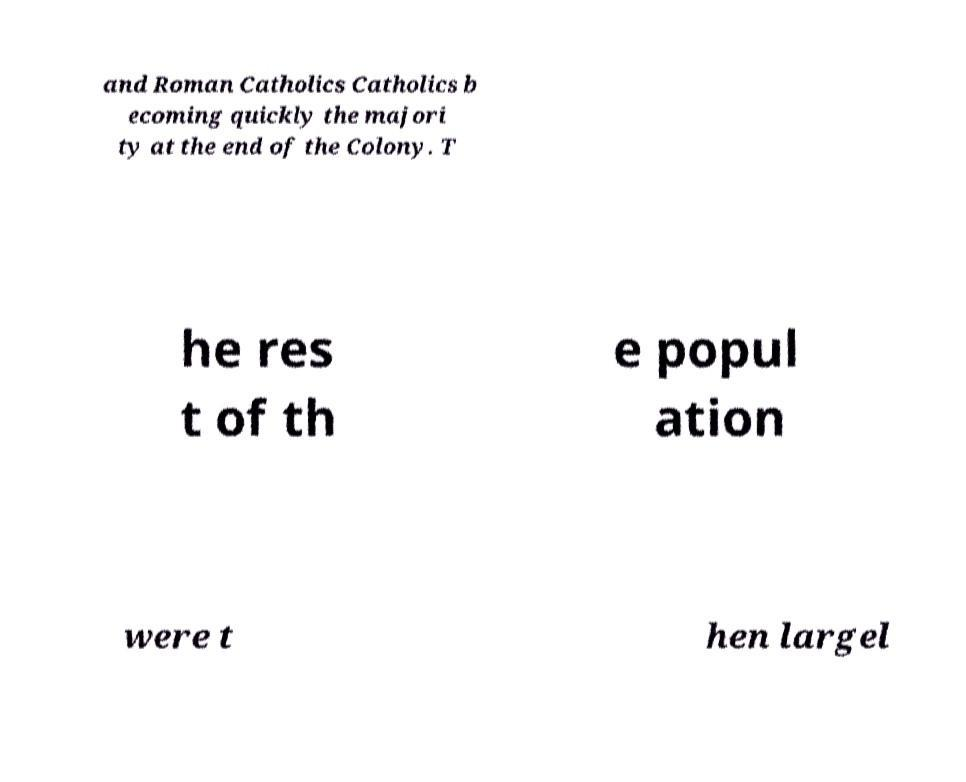There's text embedded in this image that I need extracted. Can you transcribe it verbatim? and Roman Catholics Catholics b ecoming quickly the majori ty at the end of the Colony. T he res t of th e popul ation were t hen largel 